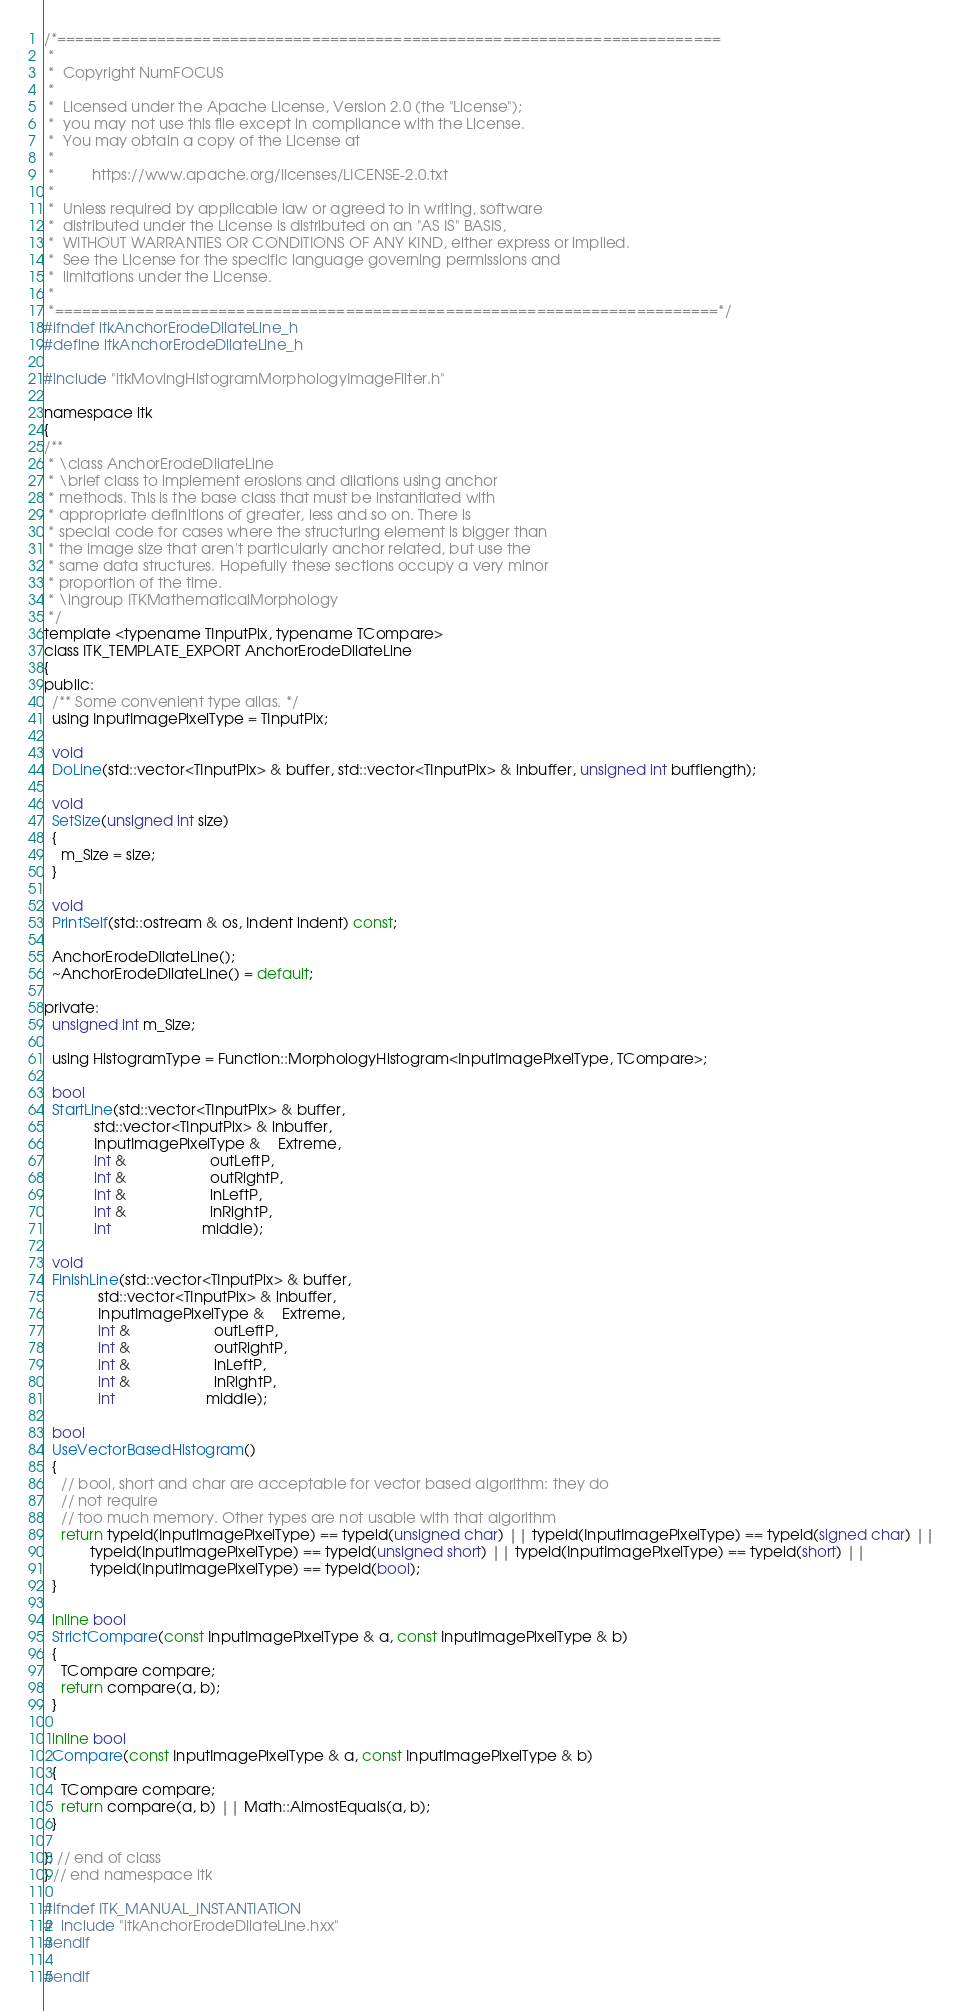Convert code to text. <code><loc_0><loc_0><loc_500><loc_500><_C_>/*=========================================================================
 *
 *  Copyright NumFOCUS
 *
 *  Licensed under the Apache License, Version 2.0 (the "License");
 *  you may not use this file except in compliance with the License.
 *  You may obtain a copy of the License at
 *
 *         https://www.apache.org/licenses/LICENSE-2.0.txt
 *
 *  Unless required by applicable law or agreed to in writing, software
 *  distributed under the License is distributed on an "AS IS" BASIS,
 *  WITHOUT WARRANTIES OR CONDITIONS OF ANY KIND, either express or implied.
 *  See the License for the specific language governing permissions and
 *  limitations under the License.
 *
 *=========================================================================*/
#ifndef itkAnchorErodeDilateLine_h
#define itkAnchorErodeDilateLine_h

#include "itkMovingHistogramMorphologyImageFilter.h"

namespace itk
{
/**
 * \class AnchorErodeDilateLine
 * \brief class to implement erosions and dilations using anchor
 * methods. This is the base class that must be instantiated with
 * appropriate definitions of greater, less and so on. There is
 * special code for cases where the structuring element is bigger than
 * the image size that aren't particularly anchor related, but use the
 * same data structures. Hopefully these sections occupy a very minor
 * proportion of the time.
 * \ingroup ITKMathematicalMorphology
 */
template <typename TInputPix, typename TCompare>
class ITK_TEMPLATE_EXPORT AnchorErodeDilateLine
{
public:
  /** Some convenient type alias. */
  using InputImagePixelType = TInputPix;

  void
  DoLine(std::vector<TInputPix> & buffer, std::vector<TInputPix> & inbuffer, unsigned int bufflength);

  void
  SetSize(unsigned int size)
  {
    m_Size = size;
  }

  void
  PrintSelf(std::ostream & os, Indent indent) const;

  AnchorErodeDilateLine();
  ~AnchorErodeDilateLine() = default;

private:
  unsigned int m_Size;

  using HistogramType = Function::MorphologyHistogram<InputImagePixelType, TCompare>;

  bool
  StartLine(std::vector<TInputPix> & buffer,
            std::vector<TInputPix> & inbuffer,
            InputImagePixelType &    Extreme,
            int &                    outLeftP,
            int &                    outRightP,
            int &                    inLeftP,
            int &                    inRightP,
            int                      middle);

  void
  FinishLine(std::vector<TInputPix> & buffer,
             std::vector<TInputPix> & inbuffer,
             InputImagePixelType &    Extreme,
             int &                    outLeftP,
             int &                    outRightP,
             int &                    inLeftP,
             int &                    inRightP,
             int                      middle);

  bool
  UseVectorBasedHistogram()
  {
    // bool, short and char are acceptable for vector based algorithm: they do
    // not require
    // too much memory. Other types are not usable with that algorithm
    return typeid(InputImagePixelType) == typeid(unsigned char) || typeid(InputImagePixelType) == typeid(signed char) ||
           typeid(InputImagePixelType) == typeid(unsigned short) || typeid(InputImagePixelType) == typeid(short) ||
           typeid(InputImagePixelType) == typeid(bool);
  }

  inline bool
  StrictCompare(const InputImagePixelType & a, const InputImagePixelType & b)
  {
    TCompare compare;
    return compare(a, b);
  }

  inline bool
  Compare(const InputImagePixelType & a, const InputImagePixelType & b)
  {
    TCompare compare;
    return compare(a, b) || Math::AlmostEquals(a, b);
  }

}; // end of class
} // end namespace itk

#ifndef ITK_MANUAL_INSTANTIATION
#  include "itkAnchorErodeDilateLine.hxx"
#endif

#endif
</code> 